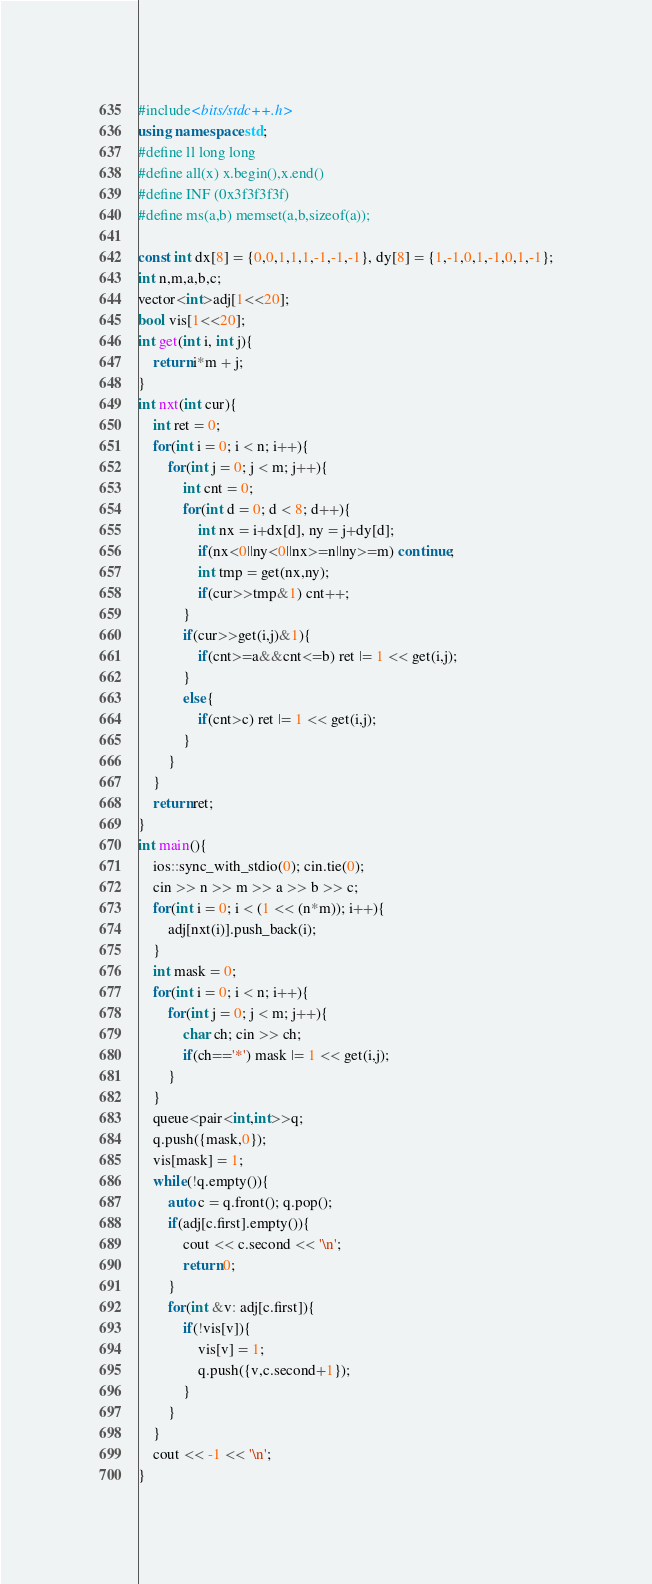<code> <loc_0><loc_0><loc_500><loc_500><_C++_>#include<bits/stdc++.h>
using namespace std;
#define ll long long
#define all(x) x.begin(),x.end()
#define INF (0x3f3f3f3f)
#define ms(a,b) memset(a,b,sizeof(a));

const int dx[8] = {0,0,1,1,1,-1,-1,-1}, dy[8] = {1,-1,0,1,-1,0,1,-1};
int n,m,a,b,c;
vector<int>adj[1<<20];
bool vis[1<<20];
int get(int i, int j){
    return i*m + j;
}
int nxt(int cur){
    int ret = 0;
    for(int i = 0; i < n; i++){
        for(int j = 0; j < m; j++){
            int cnt = 0;
            for(int d = 0; d < 8; d++){
                int nx = i+dx[d], ny = j+dy[d];
                if(nx<0||ny<0||nx>=n||ny>=m) continue;
                int tmp = get(nx,ny);
                if(cur>>tmp&1) cnt++;
            }
            if(cur>>get(i,j)&1){
                if(cnt>=a&&cnt<=b) ret |= 1 << get(i,j);
            }
            else{   
                if(cnt>c) ret |= 1 << get(i,j);
            }    
        }
    }  
    return ret; 
}
int main(){
    ios::sync_with_stdio(0); cin.tie(0);
    cin >> n >> m >> a >> b >> c; 
    for(int i = 0; i < (1 << (n*m)); i++){
        adj[nxt(i)].push_back(i);
    }
    int mask = 0;
    for(int i = 0; i < n; i++){
        for(int j = 0; j < m; j++){
            char ch; cin >> ch;
            if(ch=='*') mask |= 1 << get(i,j);
        }
    }
    queue<pair<int,int>>q;
    q.push({mask,0});
    vis[mask] = 1;
    while(!q.empty()){
        auto c = q.front(); q.pop();
        if(adj[c.first].empty()){
            cout << c.second << '\n';
            return 0;
        }
        for(int &v: adj[c.first]){
            if(!vis[v]){
                vis[v] = 1;
                q.push({v,c.second+1});
            }
        }
    }
    cout << -1 << '\n';
}</code> 